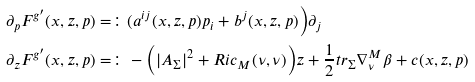<formula> <loc_0><loc_0><loc_500><loc_500>\partial _ { p } F ^ { g ^ { \prime } } ( x , z , p ) & = \colon ( a ^ { i j } ( x , z , p ) p _ { i } + b ^ { j } ( x , z , p ) \Big ) \partial _ { j } \\ \partial _ { z } F ^ { g ^ { \prime } } ( x , z , p ) & = \colon - \Big ( | A _ { \Sigma } | ^ { 2 } + R i c _ { M } ( \nu , \nu ) \Big ) z + \frac { 1 } { 2 } t r _ { \Sigma } \nabla ^ { M } _ { \nu } \beta + c ( x , z , p )</formula> 